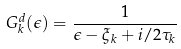Convert formula to latex. <formula><loc_0><loc_0><loc_500><loc_500>G _ { k } ^ { d } ( \epsilon ) = \frac { 1 } { \epsilon - \xi _ { k } + i / 2 \tau _ { k } }</formula> 